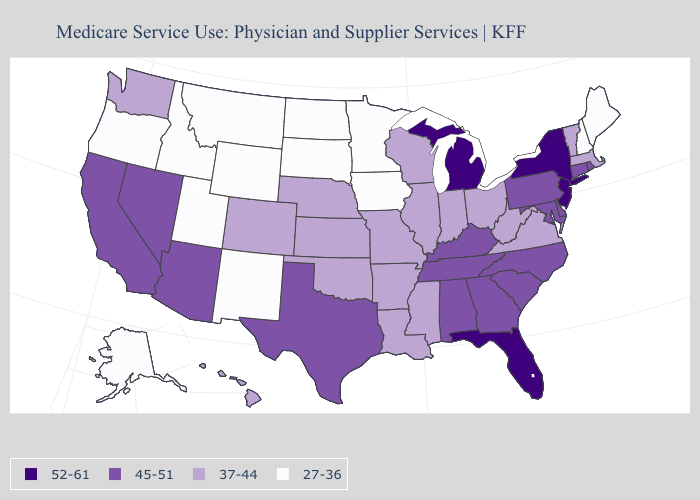What is the highest value in the USA?
Quick response, please. 52-61. What is the highest value in the USA?
Write a very short answer. 52-61. What is the value of Mississippi?
Concise answer only. 37-44. Which states have the lowest value in the West?
Quick response, please. Alaska, Idaho, Montana, New Mexico, Oregon, Utah, Wyoming. Which states have the lowest value in the West?
Give a very brief answer. Alaska, Idaho, Montana, New Mexico, Oregon, Utah, Wyoming. What is the lowest value in the West?
Keep it brief. 27-36. Name the states that have a value in the range 37-44?
Answer briefly. Arkansas, Colorado, Hawaii, Illinois, Indiana, Kansas, Louisiana, Massachusetts, Mississippi, Missouri, Nebraska, Ohio, Oklahoma, Vermont, Virginia, Washington, West Virginia, Wisconsin. What is the value of North Carolina?
Be succinct. 45-51. Name the states that have a value in the range 37-44?
Write a very short answer. Arkansas, Colorado, Hawaii, Illinois, Indiana, Kansas, Louisiana, Massachusetts, Mississippi, Missouri, Nebraska, Ohio, Oklahoma, Vermont, Virginia, Washington, West Virginia, Wisconsin. Name the states that have a value in the range 45-51?
Short answer required. Alabama, Arizona, California, Connecticut, Delaware, Georgia, Kentucky, Maryland, Nevada, North Carolina, Pennsylvania, Rhode Island, South Carolina, Tennessee, Texas. Does the map have missing data?
Short answer required. No. Is the legend a continuous bar?
Keep it brief. No. What is the lowest value in the USA?
Be succinct. 27-36. 